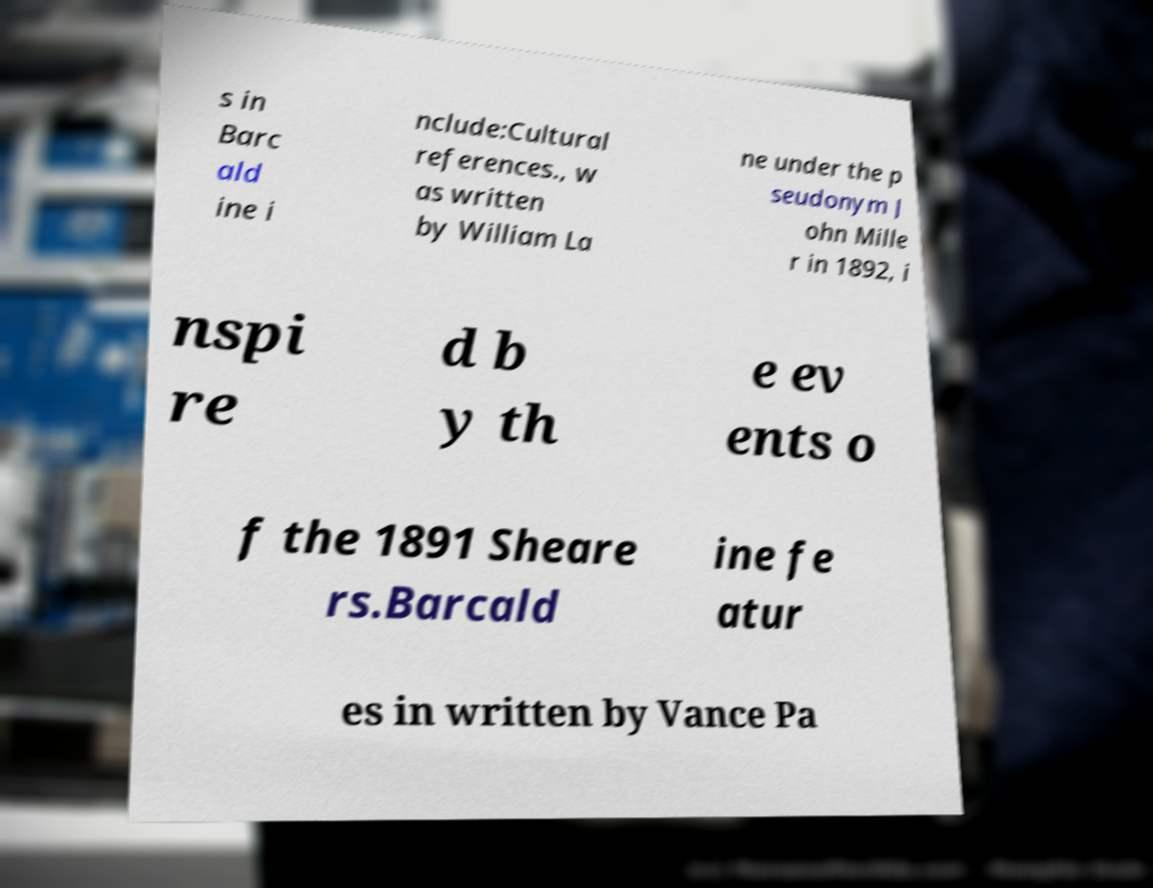What messages or text are displayed in this image? I need them in a readable, typed format. s in Barc ald ine i nclude:Cultural references., w as written by William La ne under the p seudonym J ohn Mille r in 1892, i nspi re d b y th e ev ents o f the 1891 Sheare rs.Barcald ine fe atur es in written by Vance Pa 